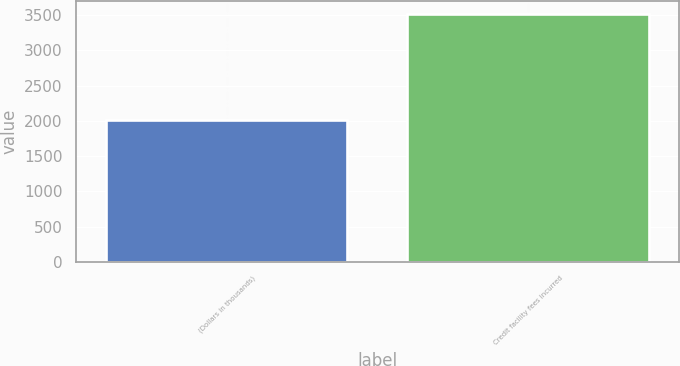<chart> <loc_0><loc_0><loc_500><loc_500><bar_chart><fcel>(Dollars in thousands)<fcel>Credit facility fees incurred<nl><fcel>2012<fcel>3519<nl></chart> 